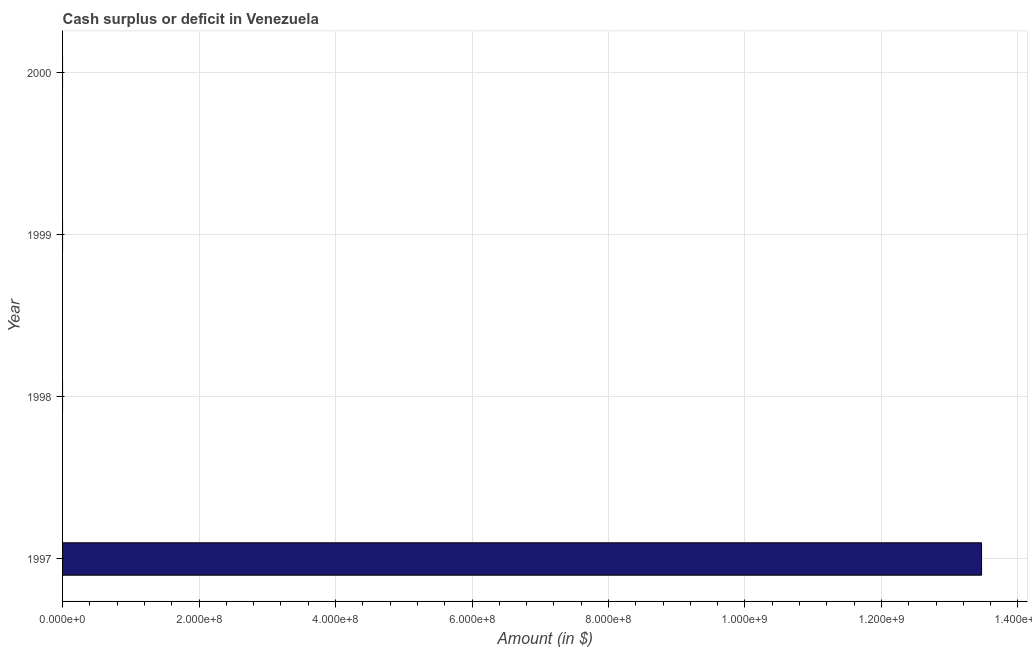Does the graph contain any zero values?
Your response must be concise. Yes. Does the graph contain grids?
Offer a very short reply. Yes. What is the title of the graph?
Ensure brevity in your answer.  Cash surplus or deficit in Venezuela. What is the label or title of the X-axis?
Offer a terse response. Amount (in $). What is the label or title of the Y-axis?
Offer a terse response. Year. What is the cash surplus or deficit in 1997?
Provide a short and direct response. 1.35e+09. Across all years, what is the maximum cash surplus or deficit?
Give a very brief answer. 1.35e+09. In which year was the cash surplus or deficit maximum?
Make the answer very short. 1997. What is the sum of the cash surplus or deficit?
Your response must be concise. 1.35e+09. What is the average cash surplus or deficit per year?
Your answer should be compact. 3.37e+08. What is the median cash surplus or deficit?
Provide a succinct answer. 0. In how many years, is the cash surplus or deficit greater than 1000000000 $?
Your answer should be compact. 1. What is the difference between the highest and the lowest cash surplus or deficit?
Offer a very short reply. 1.35e+09. In how many years, is the cash surplus or deficit greater than the average cash surplus or deficit taken over all years?
Make the answer very short. 1. How many bars are there?
Ensure brevity in your answer.  1. Are all the bars in the graph horizontal?
Ensure brevity in your answer.  Yes. What is the Amount (in $) in 1997?
Provide a succinct answer. 1.35e+09. What is the Amount (in $) of 1999?
Offer a very short reply. 0. What is the Amount (in $) in 2000?
Offer a terse response. 0. 